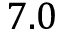Convert formula to latex. <formula><loc_0><loc_0><loc_500><loc_500>7 . 0</formula> 